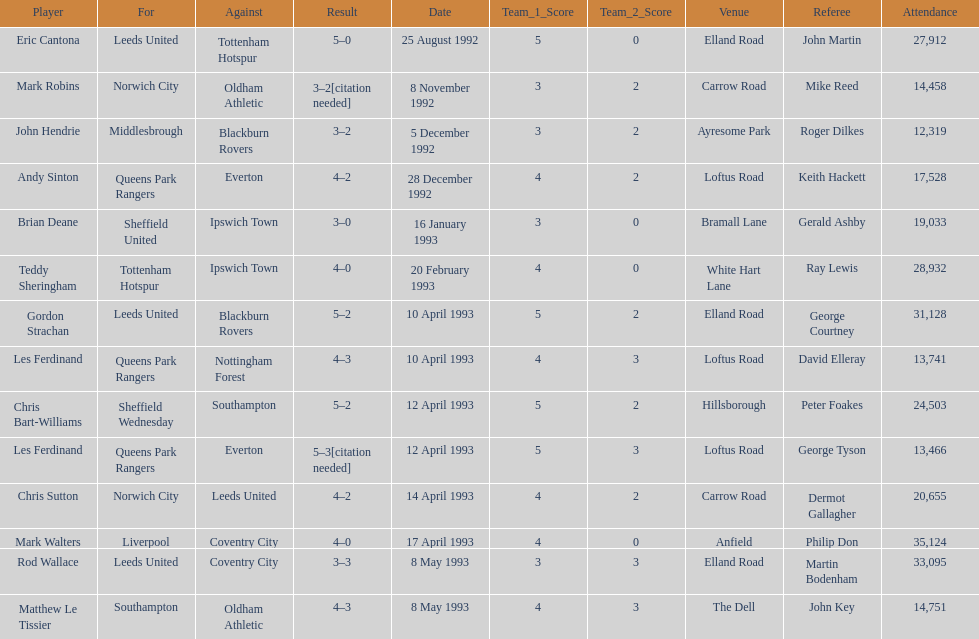On may 8th, 1993, southampton had a match, who did they face? Oldham Athletic. Could you help me parse every detail presented in this table? {'header': ['Player', 'For', 'Against', 'Result', 'Date', 'Team_1_Score', 'Team_2_Score', 'Venue', 'Referee', 'Attendance'], 'rows': [['Eric Cantona', 'Leeds United', 'Tottenham Hotspur', '5–0', '25 August 1992', '5', '0', 'Elland Road', 'John Martin', '27,912'], ['Mark Robins', 'Norwich City', 'Oldham Athletic', '3–2[citation needed]', '8 November 1992', '3', '2', 'Carrow Road', 'Mike Reed', '14,458'], ['John Hendrie', 'Middlesbrough', 'Blackburn Rovers', '3–2', '5 December 1992', '3', '2', 'Ayresome Park', 'Roger Dilkes', '12,319'], ['Andy Sinton', 'Queens Park Rangers', 'Everton', '4–2', '28 December 1992', '4', '2', 'Loftus Road', 'Keith Hackett', '17,528'], ['Brian Deane', 'Sheffield United', 'Ipswich Town', '3–0', '16 January 1993', '3', '0', 'Bramall Lane', 'Gerald Ashby', '19,033'], ['Teddy Sheringham', 'Tottenham Hotspur', 'Ipswich Town', '4–0', '20 February 1993', '4', '0', 'White Hart Lane', 'Ray Lewis', '28,932'], ['Gordon Strachan', 'Leeds United', 'Blackburn Rovers', '5–2', '10 April 1993', '5', '2', 'Elland Road', 'George Courtney', '31,128'], ['Les Ferdinand', 'Queens Park Rangers', 'Nottingham Forest', '4–3', '10 April 1993', '4', '3', 'Loftus Road', 'David Elleray', '13,741'], ['Chris Bart-Williams', 'Sheffield Wednesday', 'Southampton', '5–2', '12 April 1993', '5', '2', 'Hillsborough', 'Peter Foakes', '24,503'], ['Les Ferdinand', 'Queens Park Rangers', 'Everton', '5–3[citation needed]', '12 April 1993', '5', '3', 'Loftus Road', 'George Tyson', '13,466'], ['Chris Sutton', 'Norwich City', 'Leeds United', '4–2', '14 April 1993', '4', '2', 'Carrow Road', 'Dermot Gallagher', '20,655'], ['Mark Walters', 'Liverpool', 'Coventry City', '4–0', '17 April 1993', '4', '0', 'Anfield', 'Philip Don', '35,124'], ['Rod Wallace', 'Leeds United', 'Coventry City', '3–3', '8 May 1993', '3', '3', 'Elland Road', 'Martin Bodenham', '33,095'], ['Matthew Le Tissier', 'Southampton', 'Oldham Athletic', '4–3', '8 May 1993', '4', '3', 'The Dell', 'John Key', '14,751']]} 